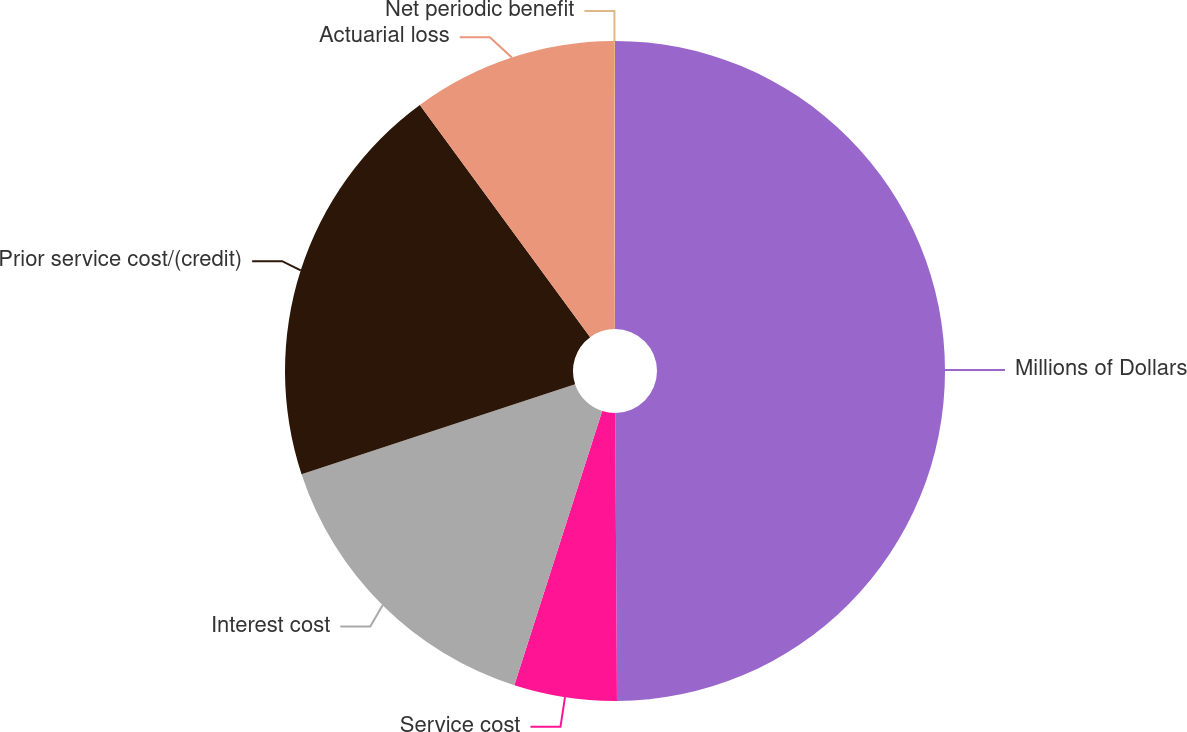Convert chart to OTSL. <chart><loc_0><loc_0><loc_500><loc_500><pie_chart><fcel>Millions of Dollars<fcel>Service cost<fcel>Interest cost<fcel>Prior service cost/(credit)<fcel>Actuarial loss<fcel>Net periodic benefit<nl><fcel>49.9%<fcel>5.03%<fcel>15.0%<fcel>19.99%<fcel>10.02%<fcel>0.05%<nl></chart> 